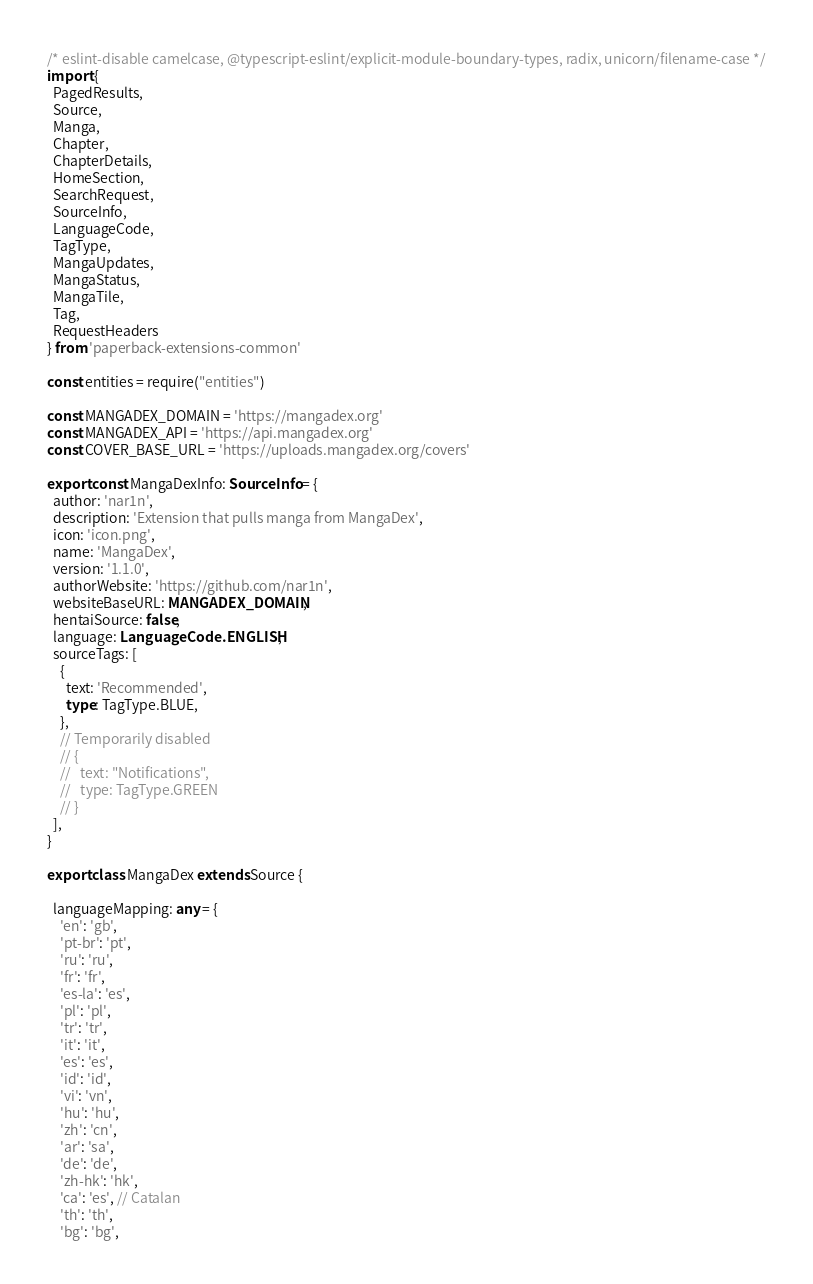<code> <loc_0><loc_0><loc_500><loc_500><_TypeScript_>/* eslint-disable camelcase, @typescript-eslint/explicit-module-boundary-types, radix, unicorn/filename-case */
import {
  PagedResults,
  Source,
  Manga,
  Chapter,
  ChapterDetails,
  HomeSection,
  SearchRequest,
  SourceInfo,
  LanguageCode,
  TagType,
  MangaUpdates,
  MangaStatus,
  MangaTile,
  Tag,
  RequestHeaders
} from 'paperback-extensions-common'

const entities = require("entities")

const MANGADEX_DOMAIN = 'https://mangadex.org'
const MANGADEX_API = 'https://api.mangadex.org'
const COVER_BASE_URL = 'https://uploads.mangadex.org/covers'

export const MangaDexInfo: SourceInfo = {
  author: 'nar1n',
  description: 'Extension that pulls manga from MangaDex',
  icon: 'icon.png',
  name: 'MangaDex',
  version: '1.1.0',
  authorWebsite: 'https://github.com/nar1n',
  websiteBaseURL: MANGADEX_DOMAIN,
  hentaiSource: false,
  language: LanguageCode.ENGLISH,
  sourceTags: [
    {
      text: 'Recommended',
      type: TagType.BLUE,
    },
    // Temporarily disabled
    // {
    //   text: "Notifications",
    //   type: TagType.GREEN
    // }
  ],
}

export class MangaDex extends Source {

  languageMapping: any = {
    'en': 'gb',
    'pt-br': 'pt',
    'ru': 'ru',
    'fr': 'fr',
    'es-la': 'es',
    'pl': 'pl',
    'tr': 'tr',
    'it': 'it',
    'es': 'es',
    'id': 'id',
    'vi': 'vn',
    'hu': 'hu',
    'zh': 'cn',
    'ar': 'sa',
    'de': 'de',
    'zh-hk': 'hk',
    'ca': 'es', // Catalan
    'th': 'th',
    'bg': 'bg',</code> 